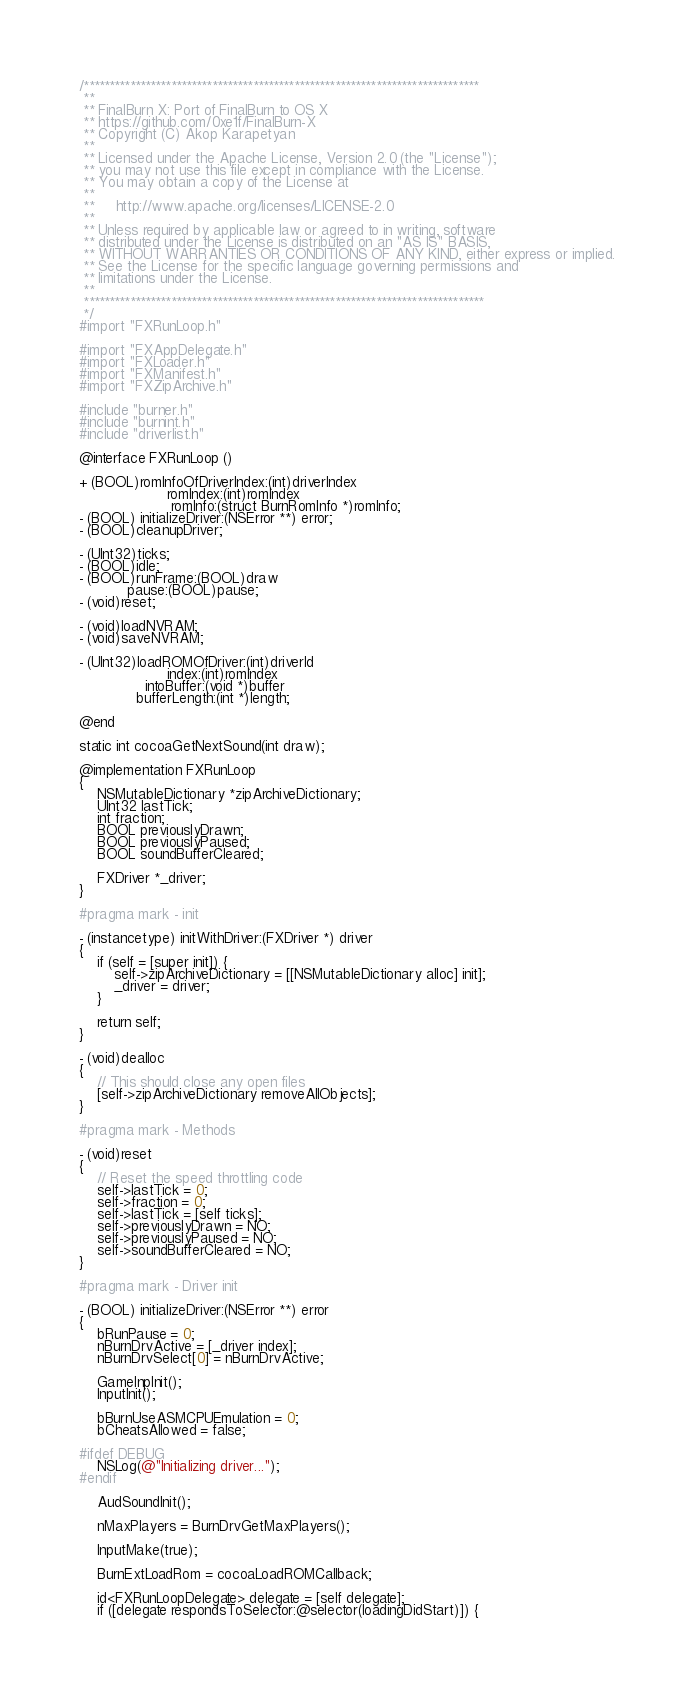<code> <loc_0><loc_0><loc_500><loc_500><_ObjectiveC_>/*****************************************************************************
 **
 ** FinalBurn X: Port of FinalBurn to OS X
 ** https://github.com/0xe1f/FinalBurn-X
 ** Copyright (C) Akop Karapetyan
 **
 ** Licensed under the Apache License, Version 2.0 (the "License");
 ** you may not use this file except in compliance with the License.
 ** You may obtain a copy of the License at
 **
 **     http://www.apache.org/licenses/LICENSE-2.0
 **
 ** Unless required by applicable law or agreed to in writing, software
 ** distributed under the License is distributed on an "AS IS" BASIS,
 ** WITHOUT WARRANTIES OR CONDITIONS OF ANY KIND, either express or implied.
 ** See the License for the specific language governing permissions and
 ** limitations under the License.
 **
 ******************************************************************************
 */
#import "FXRunLoop.h"

#import "FXAppDelegate.h"
#import "FXLoader.h"
#import "FXManifest.h"
#import "FXZipArchive.h"

#include "burner.h"
#include "burnint.h"
#include "driverlist.h"

@interface FXRunLoop ()

+ (BOOL)romInfoOfDriverIndex:(int)driverIndex
                    romIndex:(int)romIndex
                     romInfo:(struct BurnRomInfo *)romInfo;
- (BOOL) initializeDriver:(NSError **) error;
- (BOOL)cleanupDriver;

- (UInt32)ticks;
- (BOOL)idle;
- (BOOL)runFrame:(BOOL)draw
           pause:(BOOL)pause;
- (void)reset;

- (void)loadNVRAM;
- (void)saveNVRAM;

- (UInt32)loadROMOfDriver:(int)driverId
                    index:(int)romIndex
               intoBuffer:(void *)buffer
             bufferLength:(int *)length;

@end

static int cocoaGetNextSound(int draw);

@implementation FXRunLoop
{
	NSMutableDictionary *zipArchiveDictionary;
	UInt32 lastTick;
	int fraction;
	BOOL previouslyDrawn;
	BOOL previouslyPaused;
	BOOL soundBufferCleared;

	FXDriver *_driver;
}

#pragma mark - init

- (instancetype) initWithDriver:(FXDriver *) driver
{
    if (self = [super init]) {
        self->zipArchiveDictionary = [[NSMutableDictionary alloc] init];
        _driver = driver;
    }
    
    return self;
}

- (void)dealloc
{
    // This should close any open files
    [self->zipArchiveDictionary removeAllObjects];
}

#pragma mark - Methods

- (void)reset
{
    // Reset the speed throttling code
    self->lastTick = 0;
    self->fraction = 0;
    self->lastTick = [self ticks];
    self->previouslyDrawn = NO;
    self->previouslyPaused = NO;
    self->soundBufferCleared = NO;
}

#pragma mark - Driver init

- (BOOL) initializeDriver:(NSError **) error
{
	bRunPause = 0;
	nBurnDrvActive = [_driver index];
    nBurnDrvSelect[0] = nBurnDrvActive;
    
    GameInpInit();
	InputInit();
    
	bBurnUseASMCPUEmulation = 0;
 	bCheatsAllowed = false;
    
#ifdef DEBUG
    NSLog(@"Initializing driver...");
#endif
    
	AudSoundInit();
    
	nMaxPlayers = BurnDrvGetMaxPlayers();
    
	InputMake(true);
    
    BurnExtLoadRom = cocoaLoadROMCallback;
    
    id<FXRunLoopDelegate> delegate = [self delegate];
    if ([delegate respondsToSelector:@selector(loadingDidStart)]) {</code> 